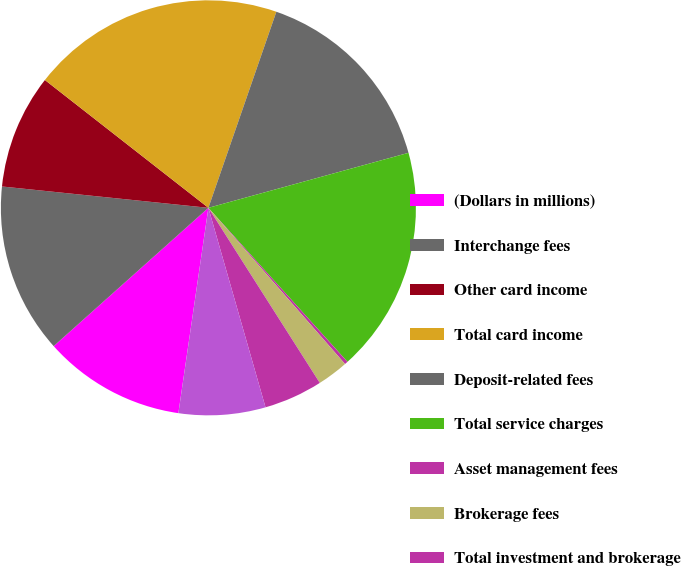Convert chart to OTSL. <chart><loc_0><loc_0><loc_500><loc_500><pie_chart><fcel>(Dollars in millions)<fcel>Interchange fees<fcel>Other card income<fcel>Total card income<fcel>Deposit-related fees<fcel>Total service charges<fcel>Asset management fees<fcel>Brokerage fees<fcel>Total investment and brokerage<fcel>Other income<nl><fcel>11.08%<fcel>13.25%<fcel>8.92%<fcel>19.75%<fcel>15.42%<fcel>17.58%<fcel>0.25%<fcel>2.42%<fcel>4.58%<fcel>6.75%<nl></chart> 